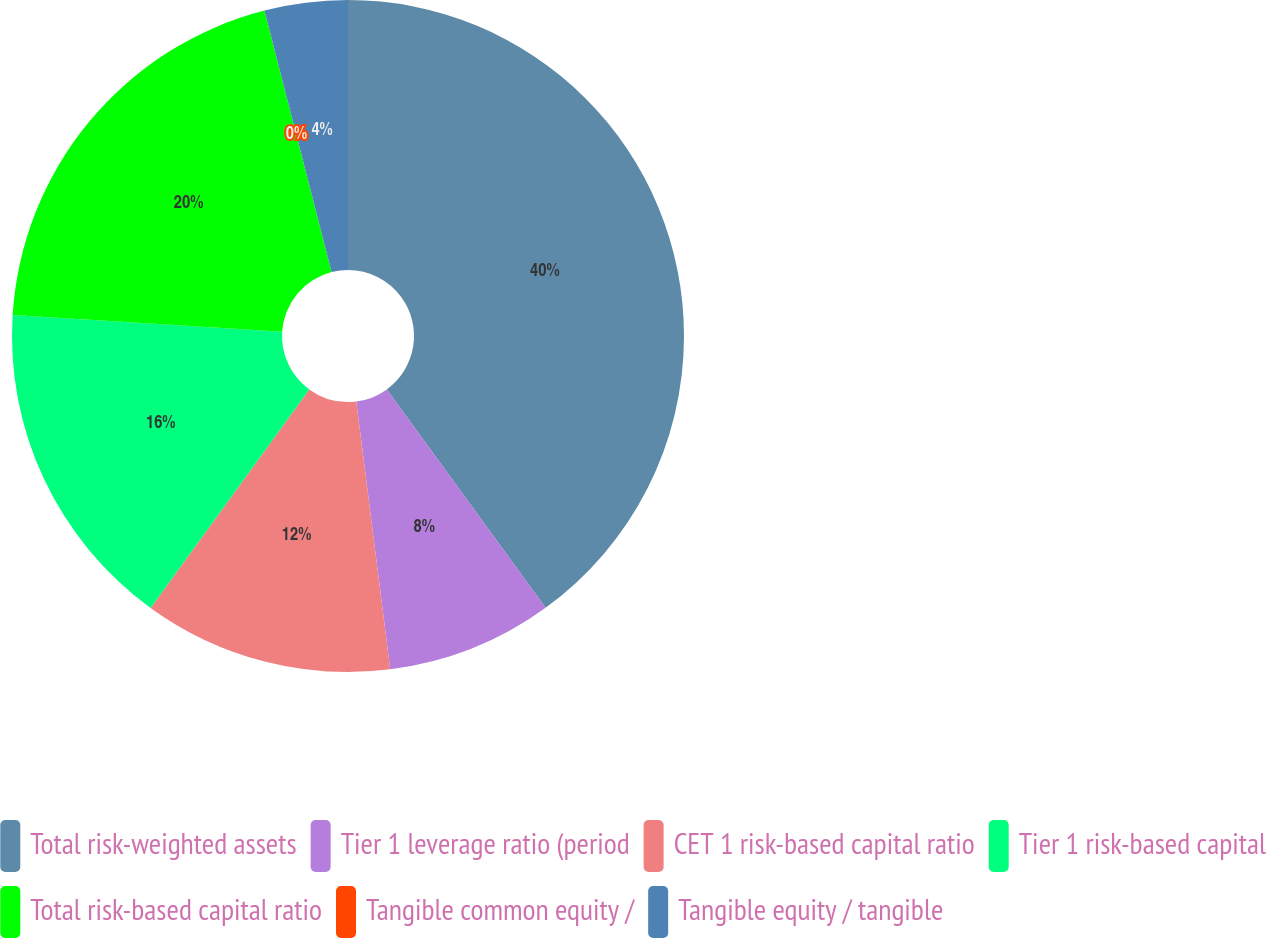Convert chart to OTSL. <chart><loc_0><loc_0><loc_500><loc_500><pie_chart><fcel>Total risk-weighted assets<fcel>Tier 1 leverage ratio (period<fcel>CET 1 risk-based capital ratio<fcel>Tier 1 risk-based capital<fcel>Total risk-based capital ratio<fcel>Tangible common equity /<fcel>Tangible equity / tangible<nl><fcel>39.99%<fcel>8.0%<fcel>12.0%<fcel>16.0%<fcel>20.0%<fcel>0.0%<fcel>4.0%<nl></chart> 